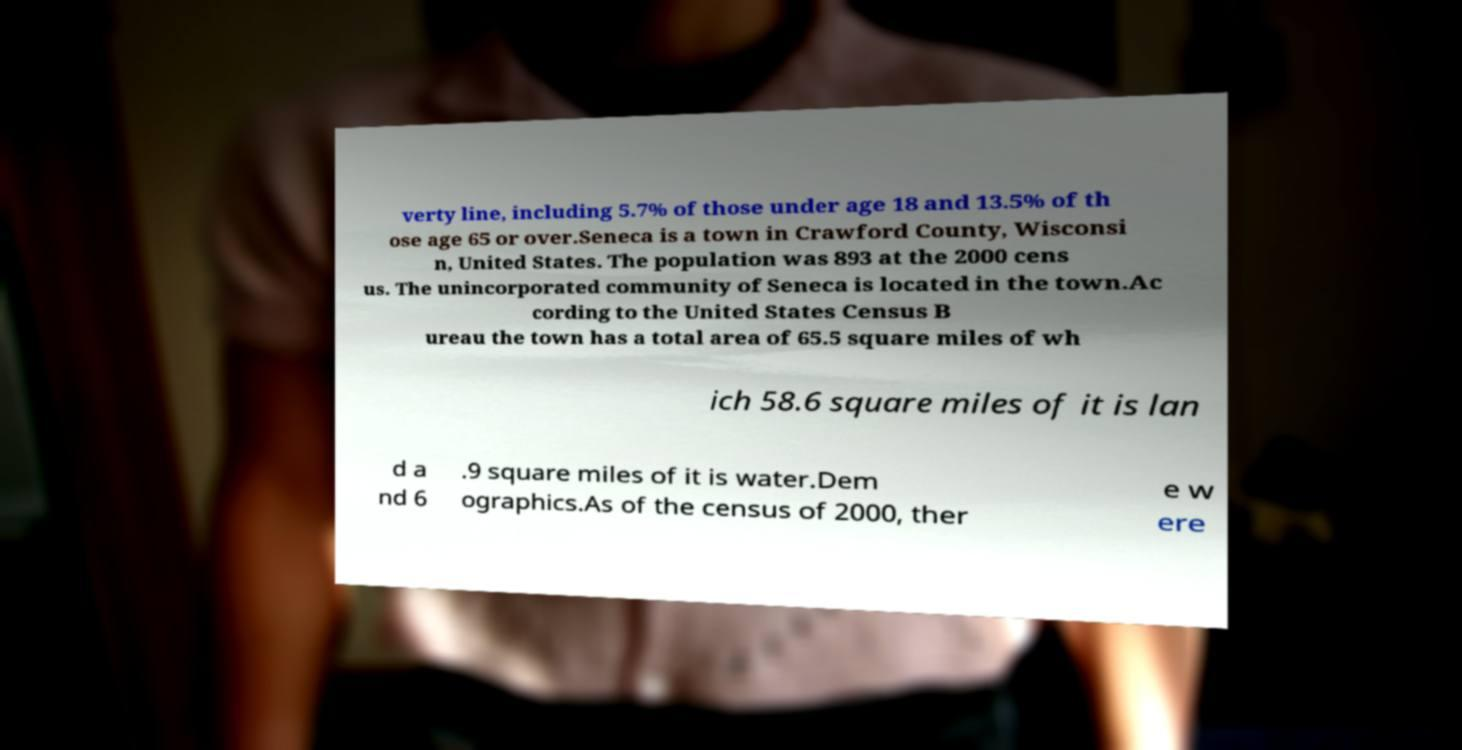Could you assist in decoding the text presented in this image and type it out clearly? verty line, including 5.7% of those under age 18 and 13.5% of th ose age 65 or over.Seneca is a town in Crawford County, Wisconsi n, United States. The population was 893 at the 2000 cens us. The unincorporated community of Seneca is located in the town.Ac cording to the United States Census B ureau the town has a total area of 65.5 square miles of wh ich 58.6 square miles of it is lan d a nd 6 .9 square miles of it is water.Dem ographics.As of the census of 2000, ther e w ere 